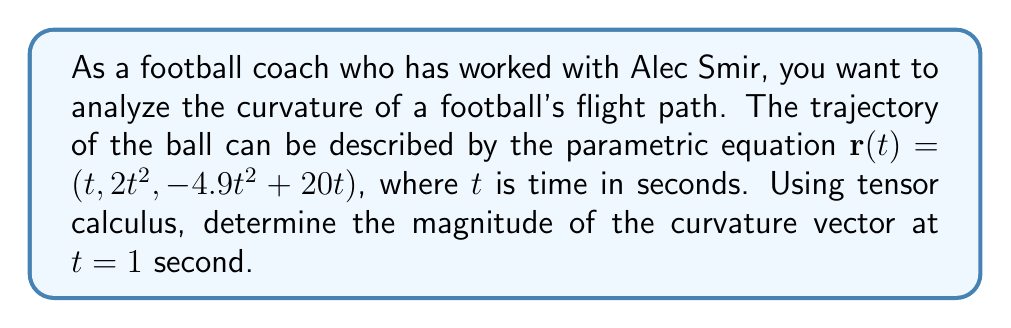What is the answer to this math problem? To find the curvature of the football's flight path using tensor calculus, we'll follow these steps:

1) First, we need to calculate the first and second derivatives of the position vector $\mathbf{r}(t)$:

   $\mathbf{r}'(t) = (1, 4t, -9.8t + 20)$
   $\mathbf{r}''(t) = (0, 4, -9.8)$

2) The curvature vector $\mathbf{\kappa}$ is given by:

   $$\mathbf{\kappa} = \frac{\mathbf{r}' \times (\mathbf{r}'' \times \mathbf{r}')}{\|\mathbf{r}'\|^3}$$

3) Let's calculate $\mathbf{r}'' \times \mathbf{r}'$ first:

   $$\mathbf{r}'' \times \mathbf{r}' = \begin{vmatrix} 
   \mathbf{i} & \mathbf{j} & \mathbf{k} \\
   0 & 4 & -9.8 \\
   1 & 4t & -9.8t+20
   \end{vmatrix} = (-39.2t+80)\mathbf{i} + 9.8\mathbf{j} + (-4)\mathbf{k}$$

4) Now, let's calculate $\mathbf{r}' \times (\mathbf{r}'' \times \mathbf{r}')$:

   $$\mathbf{r}' \times (\mathbf{r}'' \times \mathbf{r}') = \begin{vmatrix}
   \mathbf{i} & \mathbf{j} & \mathbf{k} \\
   1 & 4t & -9.8t+20 \\
   -39.2t+80 & 9.8 & -4
   \end{vmatrix}$$

   $= [(4t)(-4) - (-9.8t+20)(9.8)]\mathbf{i} + [(-9.8t+20)(-39.2t+80) - (1)(-4)]\mathbf{j} + [(1)(9.8) - (4t)(-39.2t+80)]\mathbf{k}$

5) At $t = 1$:

   $\mathbf{r}'(1) = (1, 4, 10.2)$
   $\mathbf{r}' \times (\mathbf{r}'' \times \mathbf{r}') = -113.96\mathbf{i} + 164.56\mathbf{j} + 166.6\mathbf{k}$

6) Calculate $\|\mathbf{r}'(1)\|^3$:

   $\|\mathbf{r}'(1)\|^3 = (1^2 + 4^2 + 10.2^2)^{3/2} = 11.04^3 = 1344.97$

7) Finally, calculate the magnitude of the curvature vector:

   $$\|\mathbf{\kappa}\| = \frac{\|\mathbf{r}' \times (\mathbf{r}'' \times \mathbf{r}')\|}{\|\mathbf{r}'\|^3} = \frac{\sqrt{(-113.96)^2 + 164.56^2 + 166.6^2}}{1344.97} = 0.2097$$
Answer: $0.2097$ $m^{-1}$ 